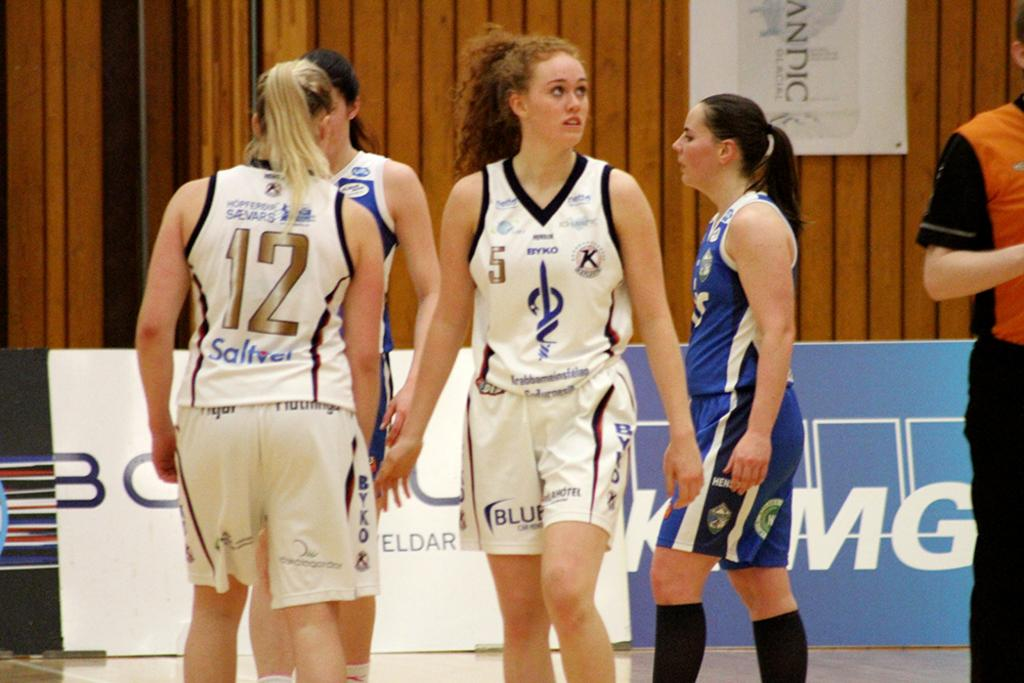<image>
Render a clear and concise summary of the photo. Women playing basketball in white jerseys with the word BYKO on them 